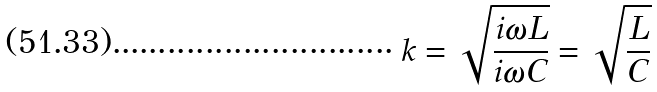<formula> <loc_0><loc_0><loc_500><loc_500>k = \sqrt { \frac { i \omega L } { i \omega C } } = \sqrt { \frac { L } { C } }</formula> 